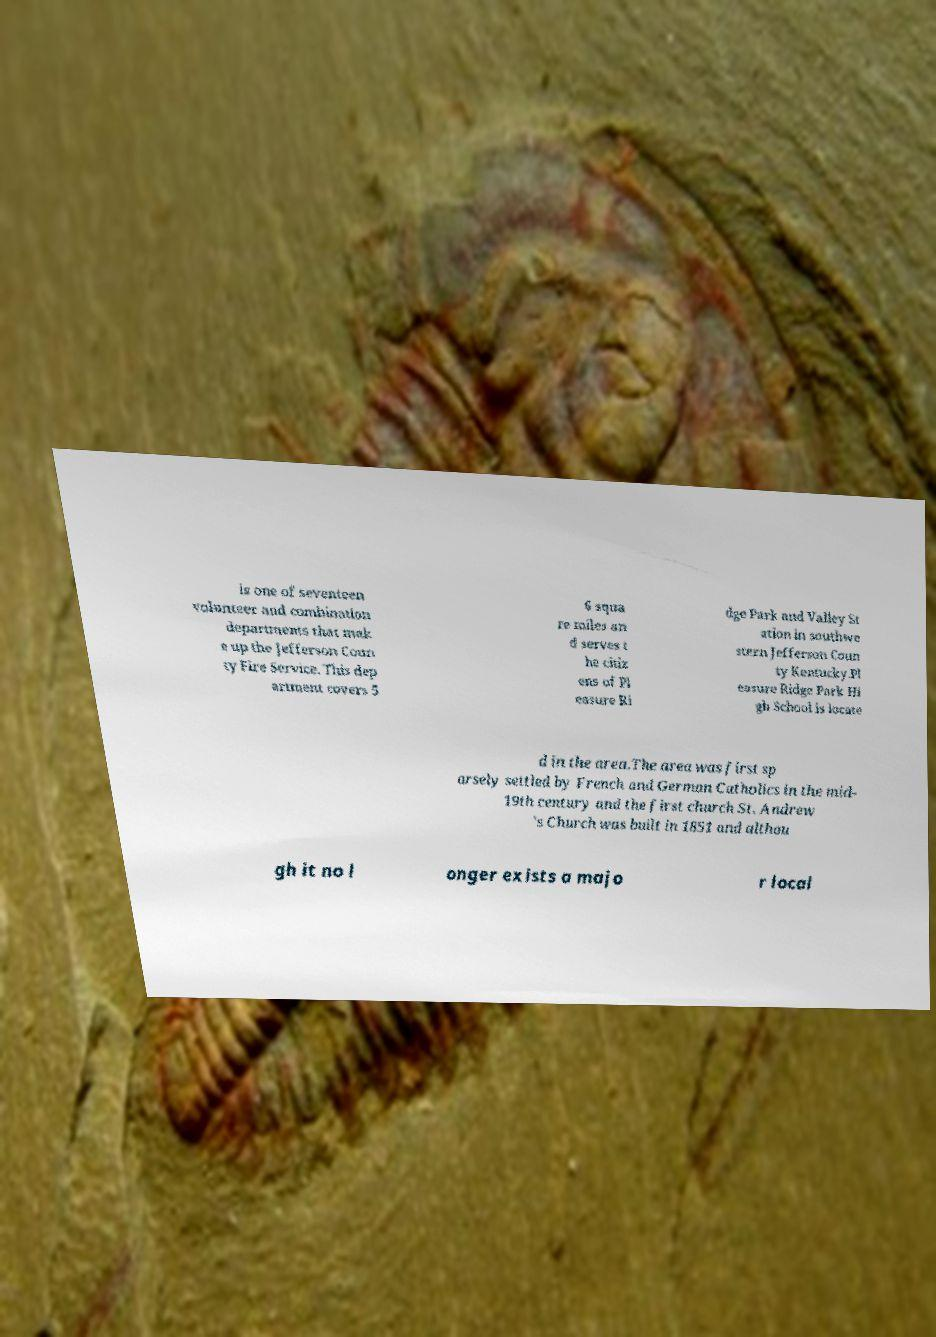I need the written content from this picture converted into text. Can you do that? is one of seventeen volunteer and combination departments that mak e up the Jefferson Coun ty Fire Service. This dep artment covers 5 6 squa re miles an d serves t he citiz ens of Pl easure Ri dge Park and Valley St ation in southwe stern Jefferson Coun ty Kentucky.Pl easure Ridge Park Hi gh School is locate d in the area.The area was first sp arsely settled by French and German Catholics in the mid- 19th century and the first church St. Andrew 's Church was built in 1851 and althou gh it no l onger exists a majo r local 